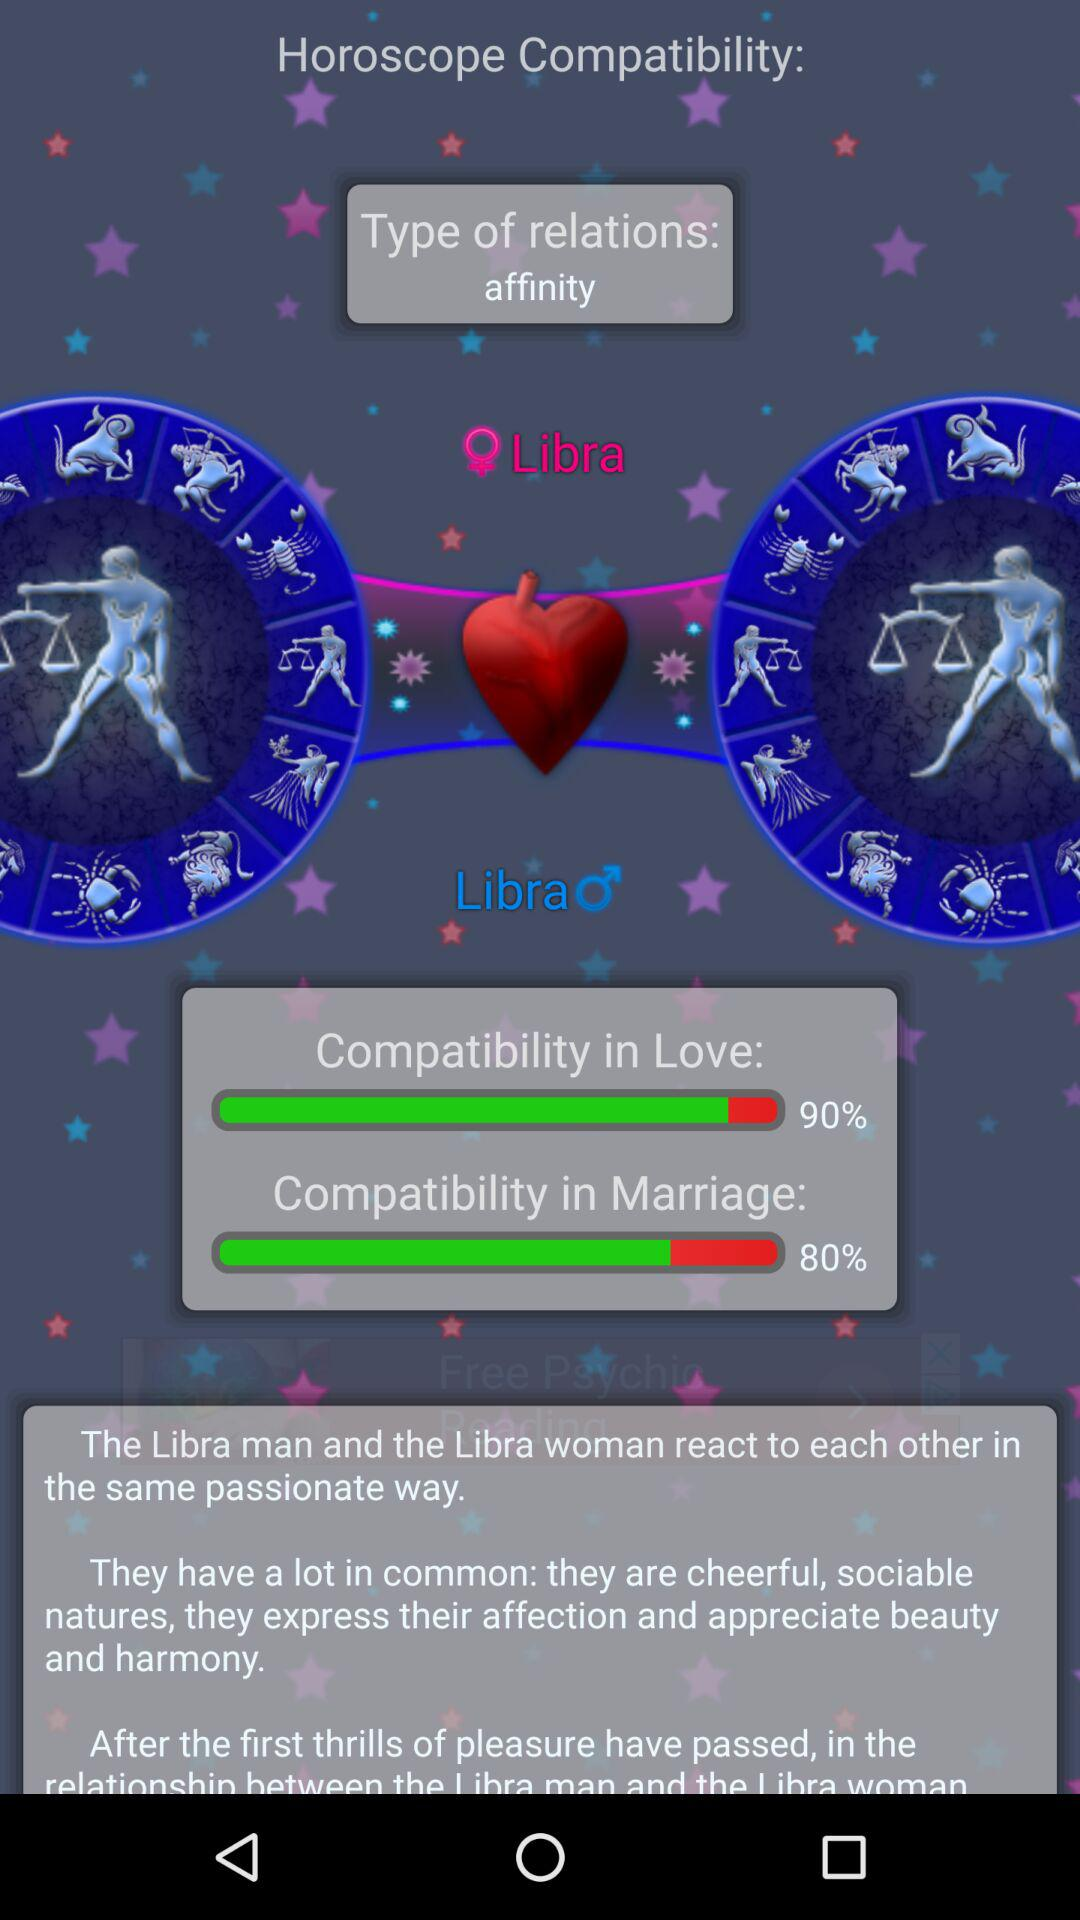What is the percentage of compatibility in marriage? The percentage is 80. 